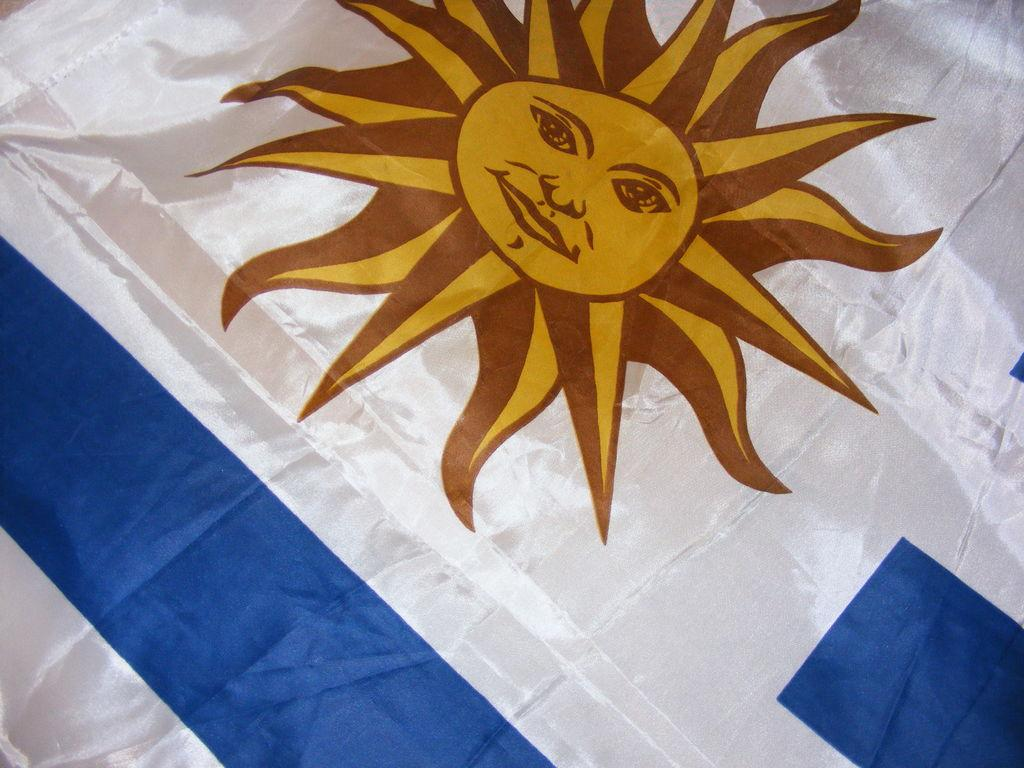What is the main object in the image? There is a flag in the image. Where can the basketball game be seen in the image? There is no basketball game present in the image; it only features a flag. What type of clocks are visible in the image? There are no clocks visible in the image; it only features a flag. 